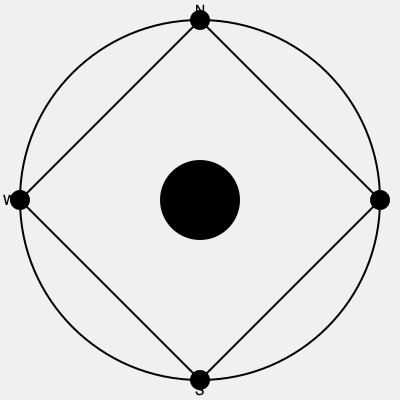Based on the aerial imagery of an ancient Aboriginal ceremonial ground, what is the ratio of the radius of the central circle to the distance between the center and any of the cardinal direction markers? To solve this problem, we need to analyze the geometric patterns in the aerial imagery:

1. The image shows a large circle with a square inscribed within it.
2. There is a smaller central circle at the center point where the square's diagonals intersect.
3. Four small circles mark the cardinal directions (N, E, S, W) at the points where the square touches the larger circle.

Let's define some variables:
- $R$: radius of the large circle
- $r$: radius of the central circle
- $d$: distance from the center to a cardinal direction marker

We can observe that:
1. The distance from the center to a cardinal direction marker ($d$) is equal to the radius of the large circle ($R$).
2. The radius of the central circle ($r$) appears to be $\frac{1}{4}$ of the distance to a cardinal marker.

Therefore:
$r = \frac{1}{4}d$

The ratio of the radius of the central circle to the distance between the center and any cardinal direction marker is:

$\frac{r}{d} = \frac{\frac{1}{4}d}{d} = \frac{1}{4}$

This ratio can be expressed as 1:4 or 0.25:1.
Answer: 1:4 